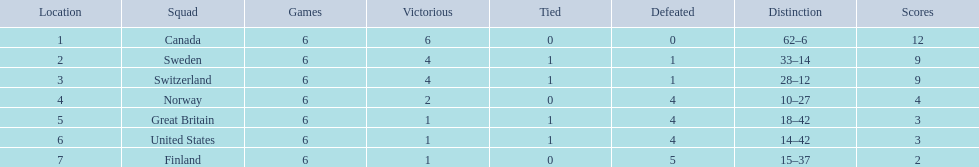How many teams won at least 4 matches? 3. 